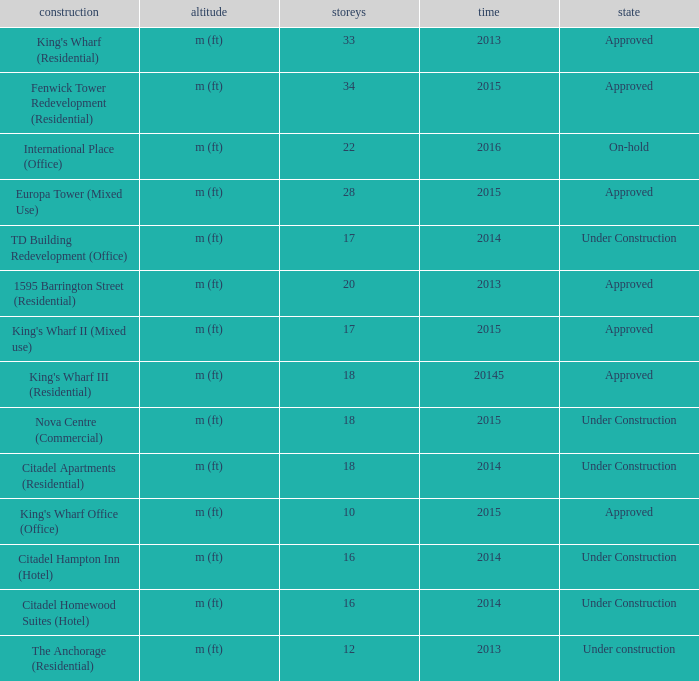What building shows 2013 and has more than 20 floors? King's Wharf (Residential). 